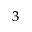<formula> <loc_0><loc_0><loc_500><loc_500>_ { 3 }</formula> 